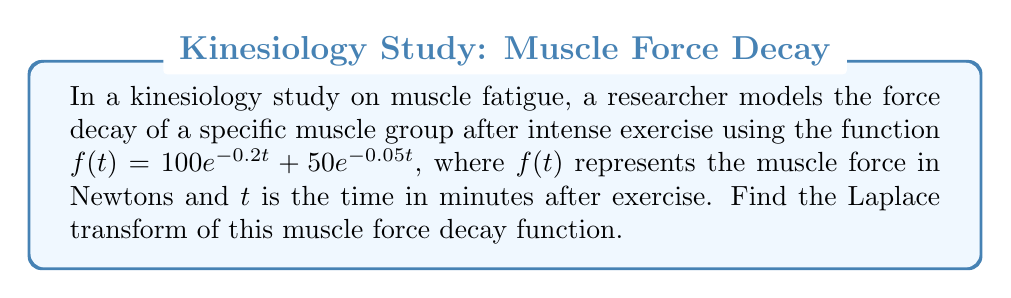Give your solution to this math problem. To solve this problem, we need to apply the Laplace transform to the given function. Let's break it down step by step:

1) The Laplace transform of a function $f(t)$ is defined as:

   $$\mathcal{L}\{f(t)\} = F(s) = \int_0^{\infty} e^{-st}f(t)dt$$

2) Our function is $f(t) = 100e^{-0.2t} + 50e^{-0.05t}$. We can use the linearity property of the Laplace transform:

   $$\mathcal{L}\{af(t) + bg(t)\} = a\mathcal{L}\{f(t)\} + b\mathcal{L}\{g(t)\}$$

3) So, we can split our problem into two parts:

   $$\mathcal{L}\{f(t)\} = \mathcal{L}\{100e^{-0.2t}\} + \mathcal{L}\{50e^{-0.05t}\}$$

4) We know that the Laplace transform of $e^{at}$ is:

   $$\mathcal{L}\{e^{at}\} = \frac{1}{s-a}$$

5) Applying this to our problem:

   $$\mathcal{L}\{100e^{-0.2t}\} = 100 \cdot \frac{1}{s+0.2}$$
   $$\mathcal{L}\{50e^{-0.05t}\} = 50 \cdot \frac{1}{s+0.05}$$

6) Combining these results:

   $$\mathcal{L}\{f(t)\} = \frac{100}{s+0.2} + \frac{50}{s+0.05}$$

This is the Laplace transform of the muscle force decay function.
Answer: $$F(s) = \frac{100}{s+0.2} + \frac{50}{s+0.05}$$ 